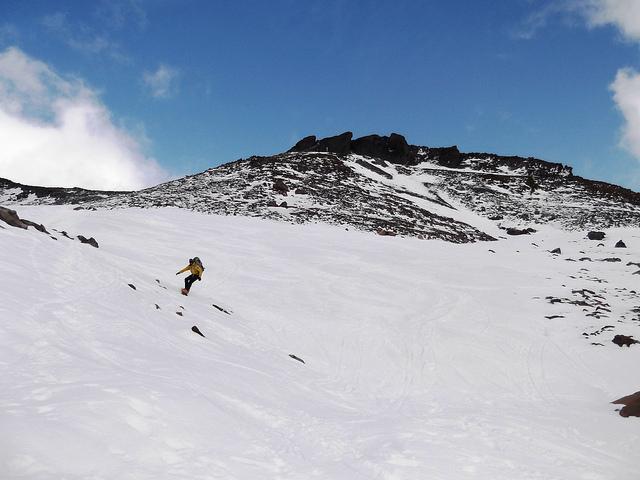What sort of weather happens here frequently?
Answer the question by selecting the correct answer among the 4 following choices and explain your choice with a short sentence. The answer should be formatted with the following format: `Answer: choice
Rationale: rationale.`
Options: Flood, rain, sleet, wind. Answer: wind.
Rationale: It must be windy for ice and snow to form. 